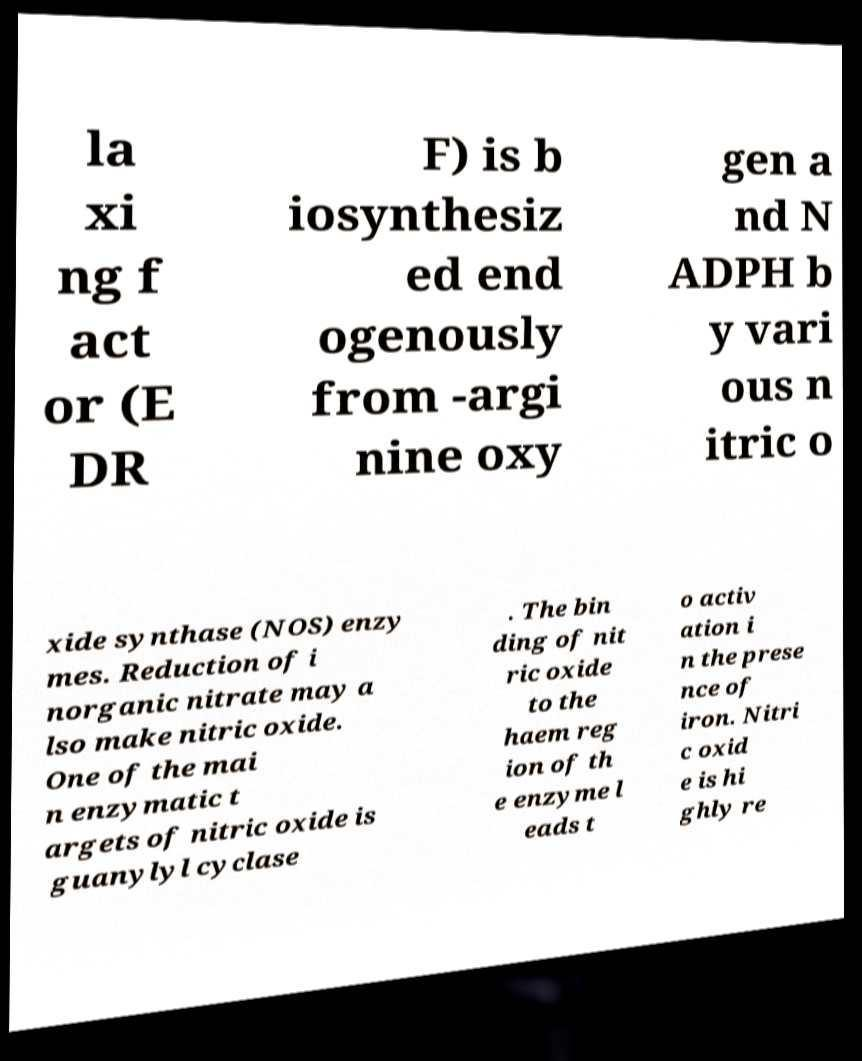Please read and relay the text visible in this image. What does it say? la xi ng f act or (E DR F) is b iosynthesiz ed end ogenously from -argi nine oxy gen a nd N ADPH b y vari ous n itric o xide synthase (NOS) enzy mes. Reduction of i norganic nitrate may a lso make nitric oxide. One of the mai n enzymatic t argets of nitric oxide is guanylyl cyclase . The bin ding of nit ric oxide to the haem reg ion of th e enzyme l eads t o activ ation i n the prese nce of iron. Nitri c oxid e is hi ghly re 